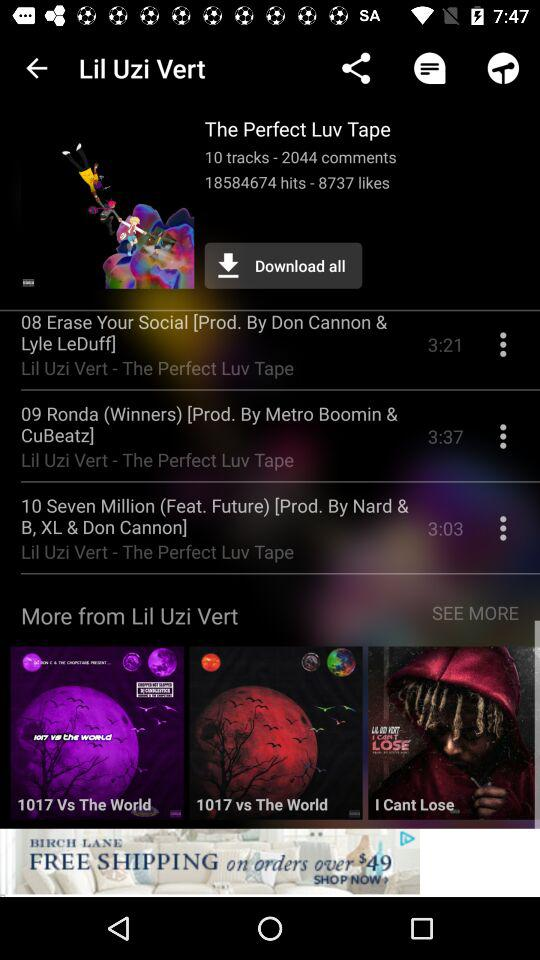How many comments in this? There are 2044 comments. 